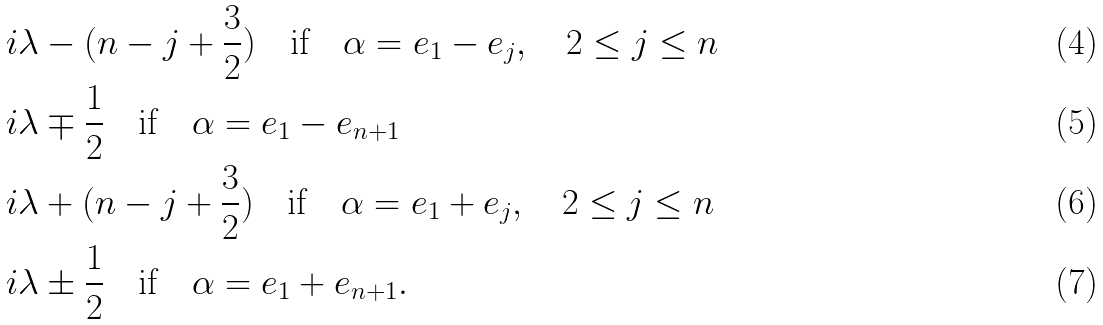<formula> <loc_0><loc_0><loc_500><loc_500>& i \lambda - ( n - j + \frac { 3 } { 2 } ) \quad \text {if} \quad \alpha = e _ { 1 } - e _ { j } , \quad 2 \leq j \leq n \\ & i \lambda \mp \frac { 1 } { 2 } \quad \text {if} \quad \alpha = e _ { 1 } - e _ { n + 1 } \\ & i \lambda + ( n - j + \frac { 3 } { 2 } ) \quad \text {if} \quad \alpha = e _ { 1 } + e _ { j } , \quad 2 \leq j \leq n \\ & i \lambda \pm \frac { 1 } { 2 } \quad \text {if} \quad \alpha = e _ { 1 } + e _ { n + 1 } .</formula> 